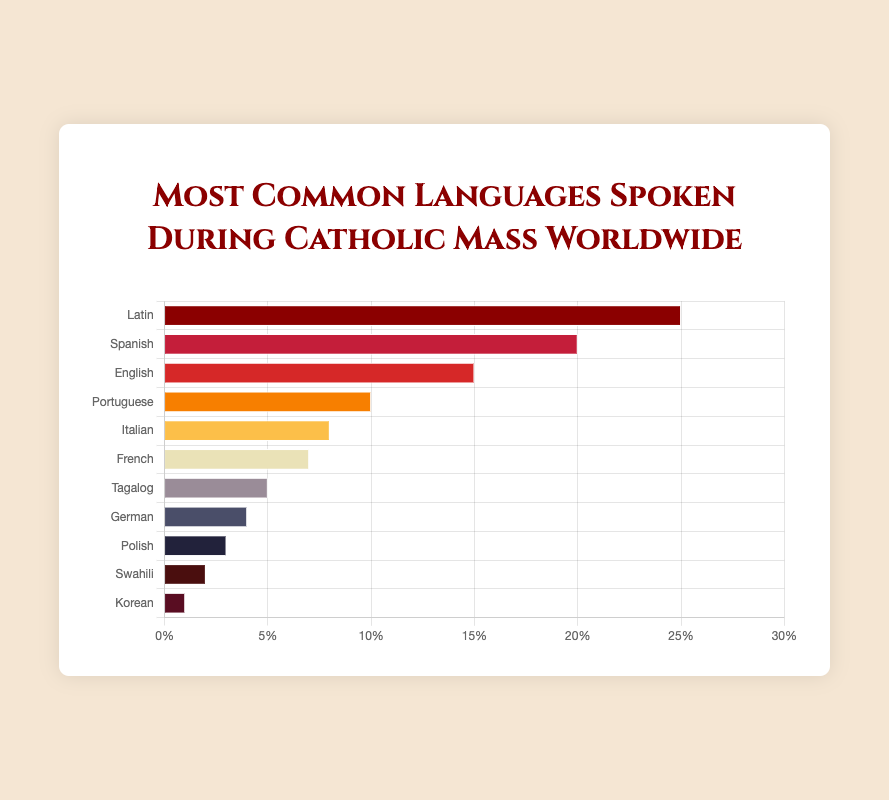What's the most common language spoken during Catholic Mass worldwide? The bar chart shows that Latin has the highest percentage among all the languages listed.
Answer: Latin Which language comes second after Latin in terms of usage in Catholic Mass? The chart indicates that Spanish has the second highest percentage after Latin.
Answer: Spanish How much more common is Latin than Korean in Catholic Mass? Latin is represented by a percentage of 25%, while Korean is 1%. The difference is 25% - 1% = 24%.
Answer: 24% What percentage of the Masses are conducted in languages other than Latin, Spanish, and English? Latin, Spanish, and English sum up to 25% + 20% + 15% = 60%. The remaining percentage is 100% - 60% = 40%.
Answer: 40% Which languages have a percentage of 10% or higher in the chart, and what are their total contributions? The languages with 10% or higher are Latin (25%), Spanish (20%), English (15%), and Portuguese (10%). Their total contribution is 25% + 20% + 15% + 10% = 70%.
Answer: 70% Compare the percentage usage of French and Italian in Catholic Mass. The bar chart shows that French is used 7% of the time, while Italian is used 8% of the time. Italian is 1% more common than French.
Answer: Italian is 1% more common What is the combined percentage for Tagalog, German, and Polish? Tagalog has 5%, German has 4%, and Polish has 3%. Therefore, their combined percentage is 5% + 4% + 3% = 12%.
Answer: 12% Which language is represented by the shortest bar? The shortest bar corresponds to the language with the smallest percentage, which is Korean (1%).
Answer: Korean Among Swahili, Polish, and Korean, which has the highest representation in the chart? Swahili has 2%, Polish has 3%, and Korean has 1%. Polish has the highest representation among them.
Answer: Polish How does the representation of French compare to that of Tagalog? French has a usage percentage of 7%, whereas Tagalog has 5%. French is represented 2% more than Tagalog.
Answer: French is 2% more common 